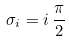<formula> <loc_0><loc_0><loc_500><loc_500>\sigma _ { i } = i \, \frac { \pi } { 2 }</formula> 